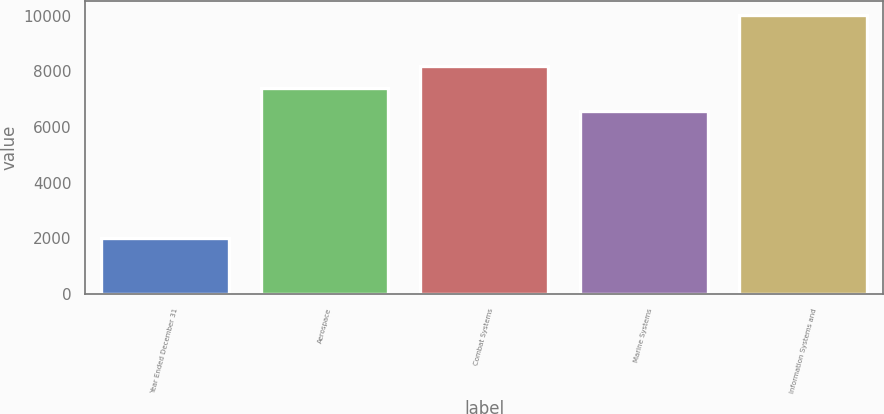<chart> <loc_0><loc_0><loc_500><loc_500><bar_chart><fcel>Year Ended December 31<fcel>Aerospace<fcel>Combat Systems<fcel>Marine Systems<fcel>Information Systems and<nl><fcel>2012<fcel>7392.5<fcel>8193<fcel>6592<fcel>10017<nl></chart> 